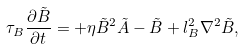<formula> <loc_0><loc_0><loc_500><loc_500>\tau _ { B } \frac { \partial \tilde { B } } { \partial t } = + \eta \tilde { B } ^ { 2 } \tilde { A } - \tilde { B } + l ^ { 2 } _ { B } \nabla ^ { 2 } \tilde { B } ,</formula> 